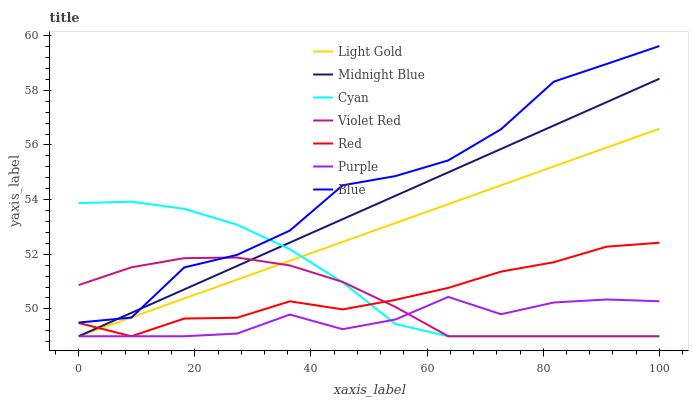Does Purple have the minimum area under the curve?
Answer yes or no. Yes. Does Blue have the maximum area under the curve?
Answer yes or no. Yes. Does Violet Red have the minimum area under the curve?
Answer yes or no. No. Does Violet Red have the maximum area under the curve?
Answer yes or no. No. Is Light Gold the smoothest?
Answer yes or no. Yes. Is Blue the roughest?
Answer yes or no. Yes. Is Violet Red the smoothest?
Answer yes or no. No. Is Violet Red the roughest?
Answer yes or no. No. Does Violet Red have the lowest value?
Answer yes or no. Yes. Does Blue have the highest value?
Answer yes or no. Yes. Does Violet Red have the highest value?
Answer yes or no. No. Is Purple less than Blue?
Answer yes or no. Yes. Is Blue greater than Purple?
Answer yes or no. Yes. Does Purple intersect Light Gold?
Answer yes or no. Yes. Is Purple less than Light Gold?
Answer yes or no. No. Is Purple greater than Light Gold?
Answer yes or no. No. Does Purple intersect Blue?
Answer yes or no. No. 